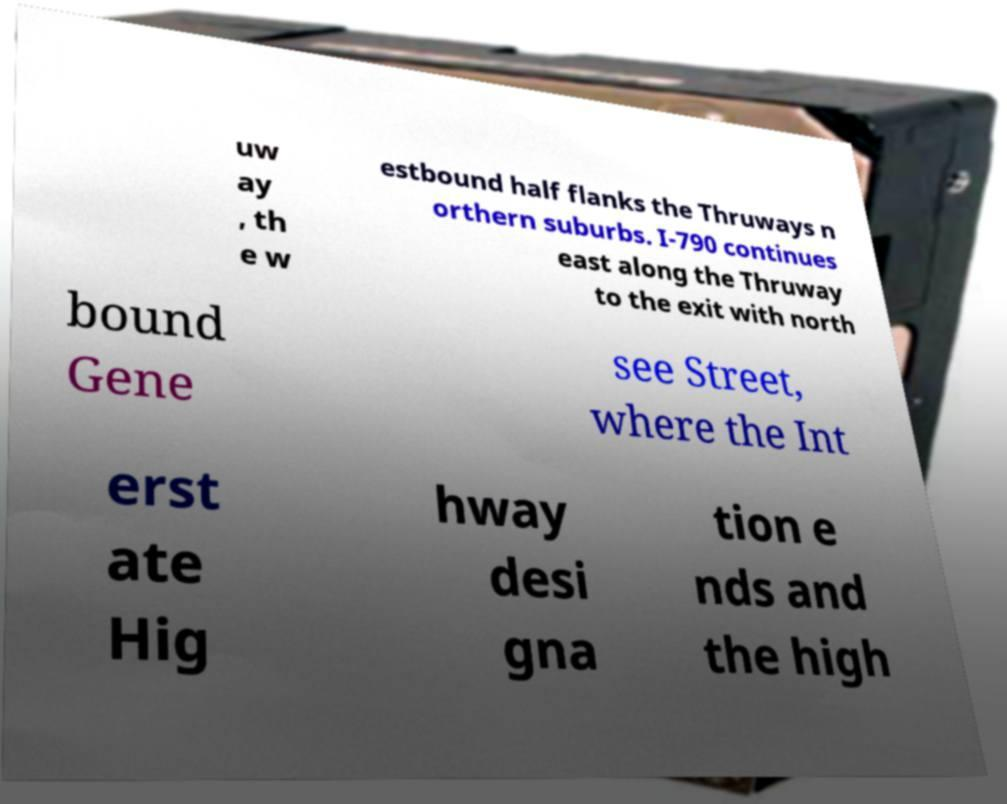Please identify and transcribe the text found in this image. uw ay , th e w estbound half flanks the Thruways n orthern suburbs. I-790 continues east along the Thruway to the exit with north bound Gene see Street, where the Int erst ate Hig hway desi gna tion e nds and the high 